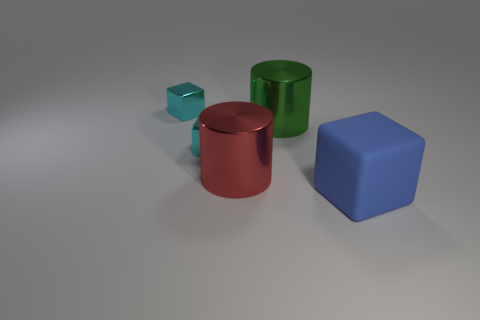How many blocks are in front of the big green object and to the left of the big blue rubber object?
Make the answer very short. 1. There is a shiny object right of the red metallic thing; is its shape the same as the large blue rubber object?
Your answer should be very brief. No. There is a green thing that is the same size as the blue rubber object; what is it made of?
Give a very brief answer. Metal. Is the number of blue rubber things that are in front of the blue rubber block the same as the number of small shiny things behind the green shiny thing?
Make the answer very short. No. What number of metal objects are behind the small cyan block that is in front of the small cyan shiny cube behind the green object?
Ensure brevity in your answer.  2. Does the large matte thing have the same color as the metal cube in front of the big green metal object?
Make the answer very short. No. There is a green cylinder that is the same material as the big red cylinder; what size is it?
Offer a very short reply. Large. Is the number of big blue things behind the big rubber thing greater than the number of green metallic cylinders?
Your answer should be very brief. No. There is a cyan cube that is to the right of the cyan cube behind the metallic cylinder right of the big red metallic cylinder; what is its material?
Provide a short and direct response. Metal. Do the big red cylinder and the cube behind the big green metallic object have the same material?
Ensure brevity in your answer.  Yes. 